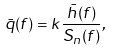<formula> <loc_0><loc_0><loc_500><loc_500>\bar { q } ( f ) = k \frac { \bar { h } ( f ) } { S _ { n } ( f ) } ,</formula> 